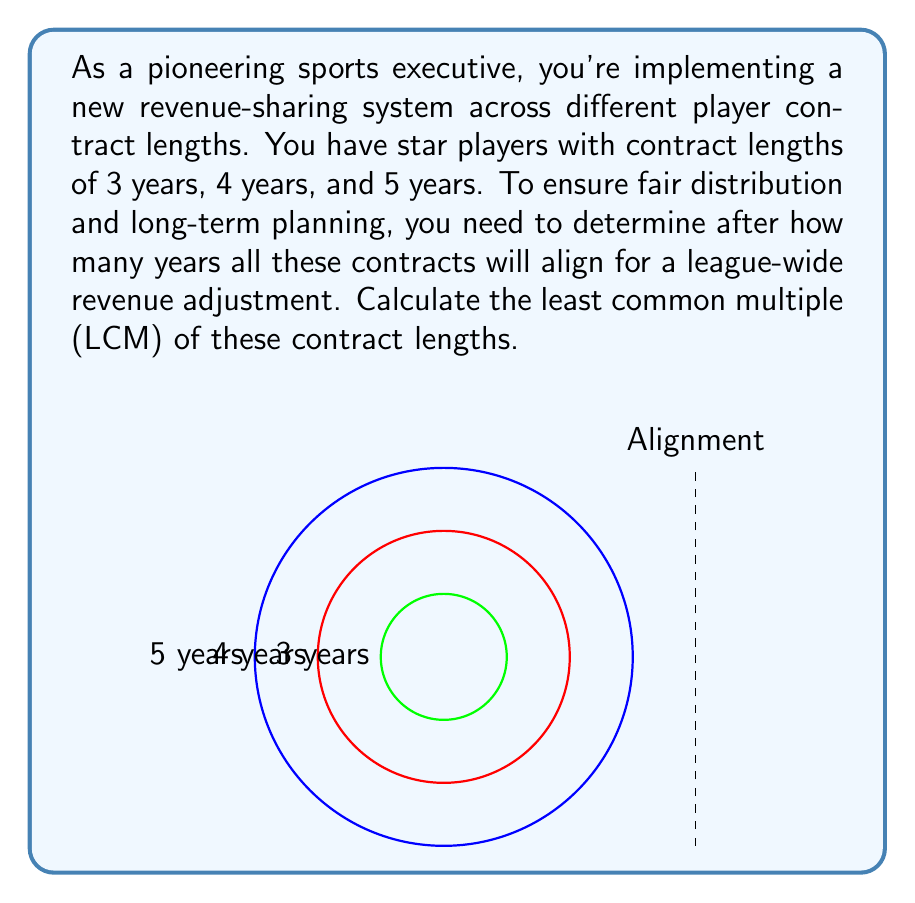Give your solution to this math problem. To find the least common multiple (LCM) of 3, 4, and 5, we'll follow these steps:

1) First, let's find the prime factorization of each number:
   $3 = 3$
   $4 = 2^2$
   $5 = 5$

2) The LCM will include the highest power of each prime factor from these factorizations:
   LCM = $2^2 \times 3 \times 5$

3) Now, let's calculate this:
   $LCM = 4 \times 3 \times 5 = 60$

4) We can verify this by dividing 60 by each of our original numbers:
   $60 \div 3 = 20$ (whole number)
   $60 \div 4 = 15$ (whole number)
   $60 \div 5 = 12$ (whole number)

Therefore, 60 is the least common multiple of 3, 4, and 5. This means that after 60 years, all contract cycles will align for a league-wide revenue adjustment.
Answer: 60 years 